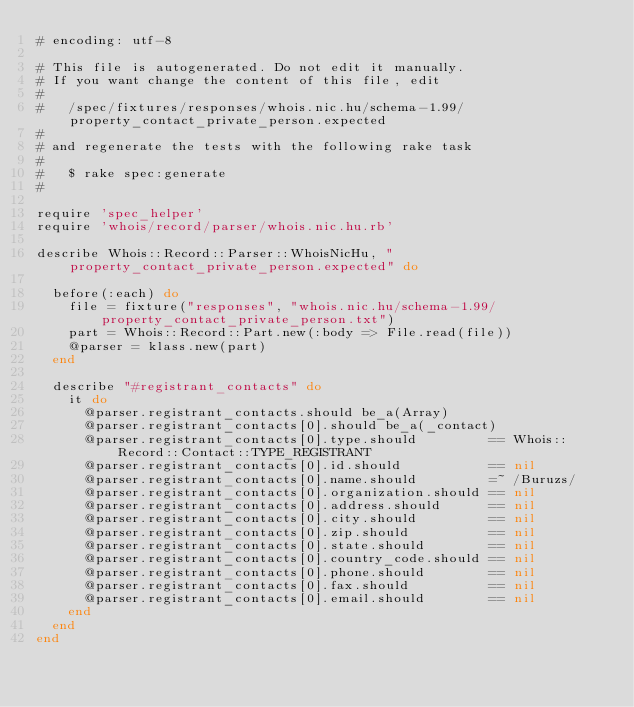Convert code to text. <code><loc_0><loc_0><loc_500><loc_500><_Ruby_># encoding: utf-8

# This file is autogenerated. Do not edit it manually.
# If you want change the content of this file, edit
#
#   /spec/fixtures/responses/whois.nic.hu/schema-1.99/property_contact_private_person.expected
#
# and regenerate the tests with the following rake task
#
#   $ rake spec:generate
#

require 'spec_helper'
require 'whois/record/parser/whois.nic.hu.rb'

describe Whois::Record::Parser::WhoisNicHu, "property_contact_private_person.expected" do

  before(:each) do
    file = fixture("responses", "whois.nic.hu/schema-1.99/property_contact_private_person.txt")
    part = Whois::Record::Part.new(:body => File.read(file))
    @parser = klass.new(part)
  end

  describe "#registrant_contacts" do
    it do
      @parser.registrant_contacts.should be_a(Array)
      @parser.registrant_contacts[0].should be_a(_contact)
      @parser.registrant_contacts[0].type.should         == Whois::Record::Contact::TYPE_REGISTRANT
      @parser.registrant_contacts[0].id.should           == nil
      @parser.registrant_contacts[0].name.should         =~ /Buruzs/
      @parser.registrant_contacts[0].organization.should == nil
      @parser.registrant_contacts[0].address.should      == nil
      @parser.registrant_contacts[0].city.should         == nil
      @parser.registrant_contacts[0].zip.should          == nil
      @parser.registrant_contacts[0].state.should        == nil
      @parser.registrant_contacts[0].country_code.should == nil
      @parser.registrant_contacts[0].phone.should        == nil
      @parser.registrant_contacts[0].fax.should          == nil
      @parser.registrant_contacts[0].email.should        == nil
    end
  end
end
</code> 